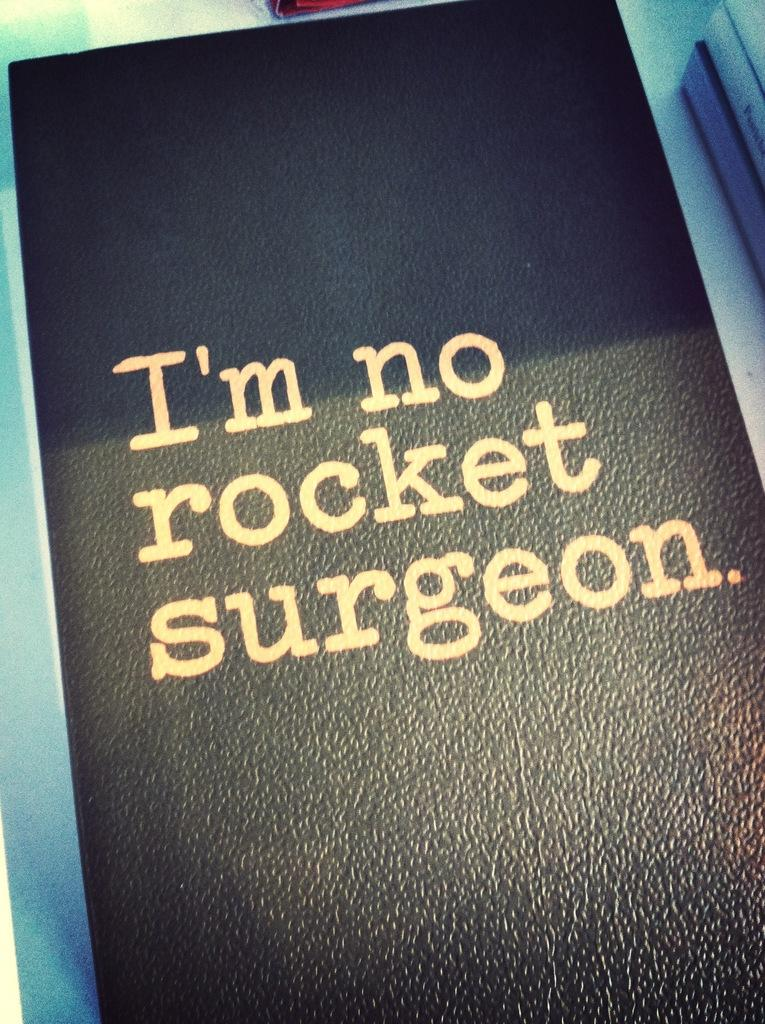<image>
Render a clear and concise summary of the photo. A book on a table titled I'm no rocket surgeon. 